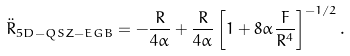<formula> <loc_0><loc_0><loc_500><loc_500>\ddot { R } _ { 5 D - Q S Z - E G B } = - \frac { R } { 4 \alpha } + \frac { R } { 4 \alpha } \left [ 1 + 8 \alpha \frac { F } { R ^ { 4 } } \right ] ^ { - 1 / 2 } .</formula> 